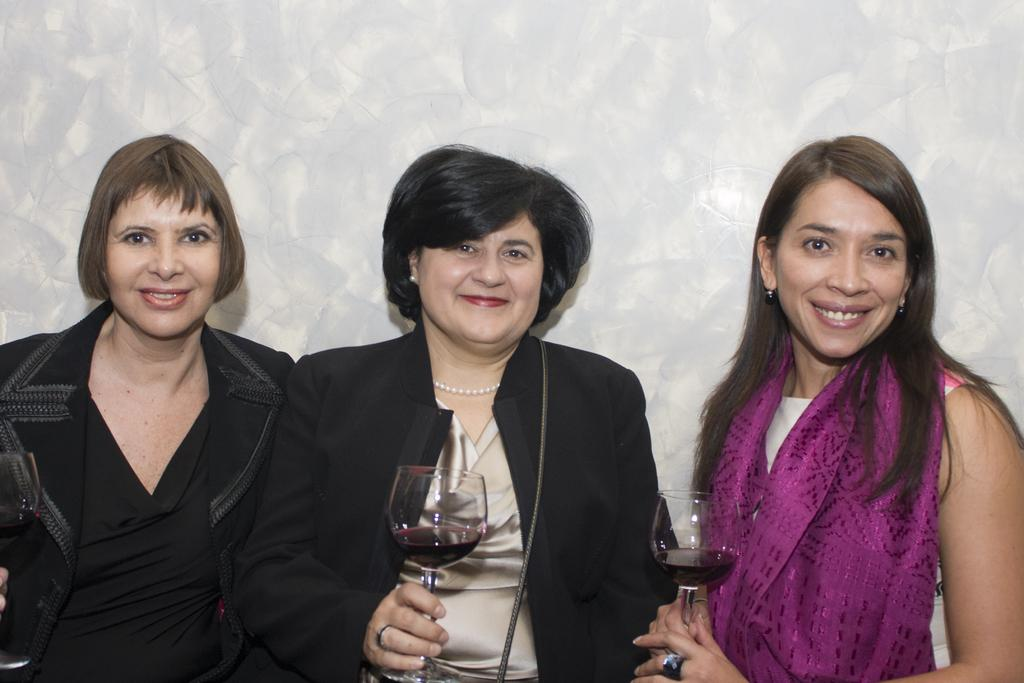How many women are present in the image? There are three women in the image. What is the second woman holding? The second woman is holding a glass. Can you describe the expression of the third woman? The third woman is smiling. What type of star can be seen in the image? There is no star present in the image. What type of meeting is taking place in the image? There is no meeting depicted in the image. 